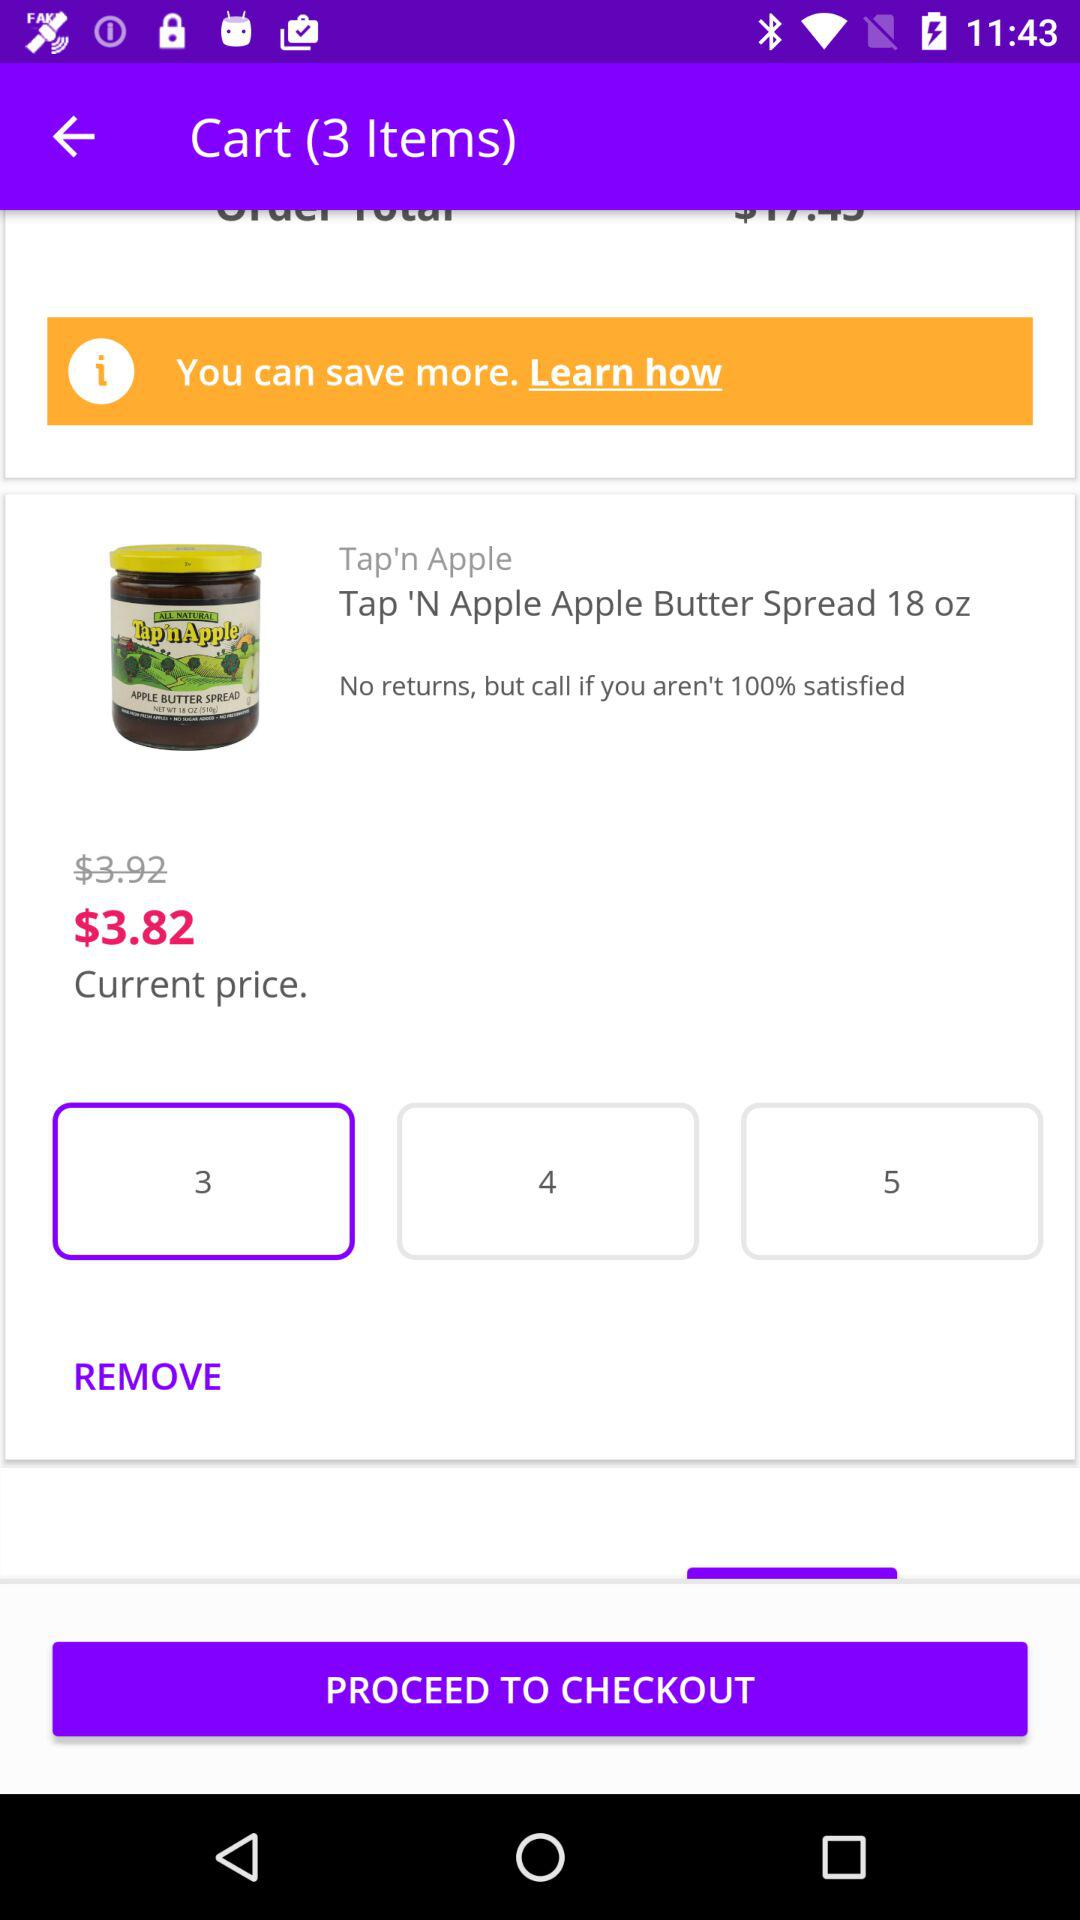How many items are available in the cart? There are 3 items available in the cart. 